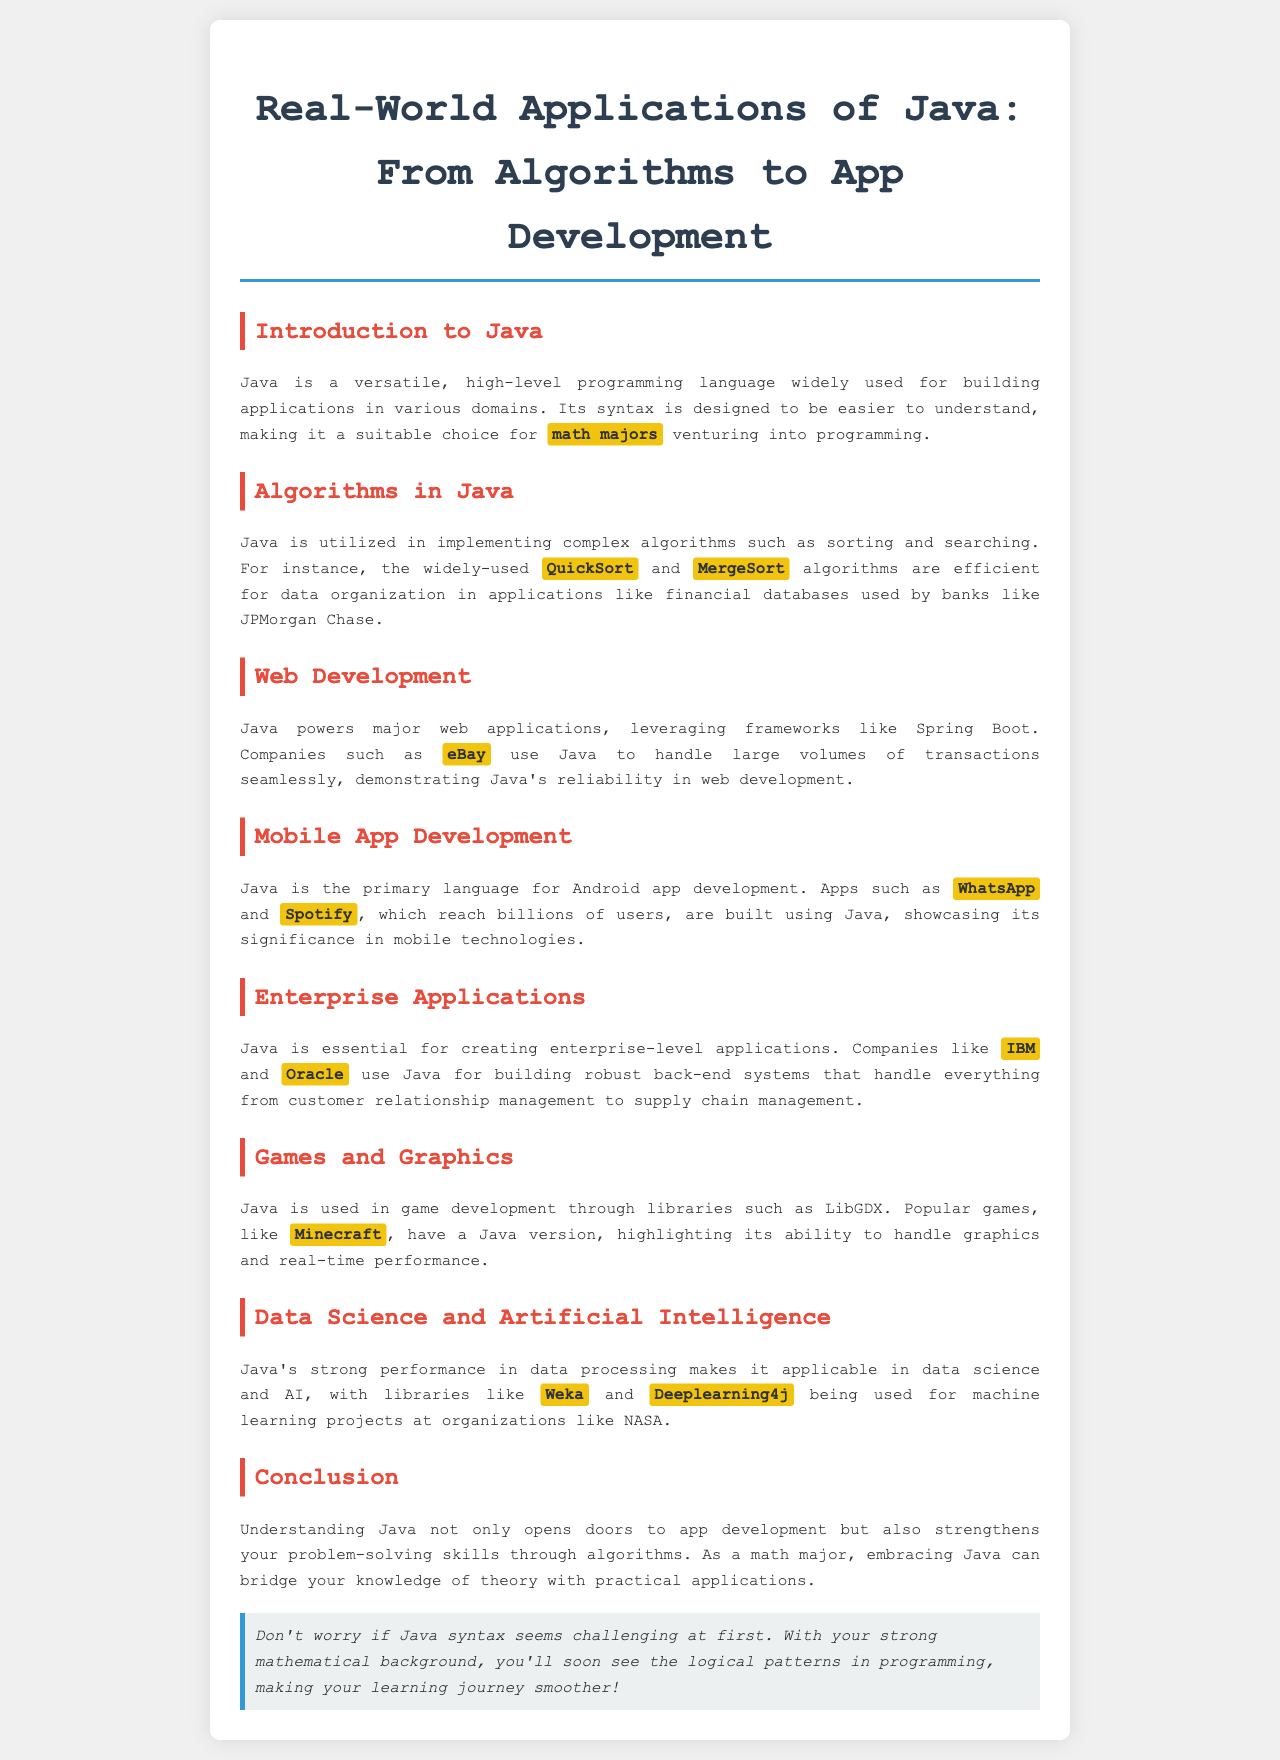What is the primary language for Android app development? The document states that Java is the primary language for Android app development.
Answer: Java Which company uses Java for large transaction volumes? The document mentions that eBay uses Java to handle large volumes of transactions seamlessly.
Answer: eBay Name one algorithm mentioned in the brochure. The document refers to QuickSort and MergeSort algorithms.
Answer: QuickSort What game is highlighted as having a Java version? The document highlights Minecraft as a popular game with a Java version.
Answer: Minecraft Which two companies are mentioned for creating enterprise applications? The document lists IBM and Oracle as companies that use Java for enterprise applications.
Answer: IBM and Oracle What type of applications does Java handle in data science? The document refers to machine learning projects in data science and AI where Java is applied.
Answer: Machine learning projects What is a noted benefit of understanding Java for math majors? The document suggests that understanding Java strengthens problem-solving skills through algorithms.
Answer: Problem-solving skills Which library is mentioned for game development in Java? The document mentions LibGDX as a library used in game development with Java.
Answer: LibGDX What does the note at the end of the document reassure about Java syntax? The note reassures that learning Java syntax might seem challenging but logical patterns will emerge.
Answer: Logical patterns 